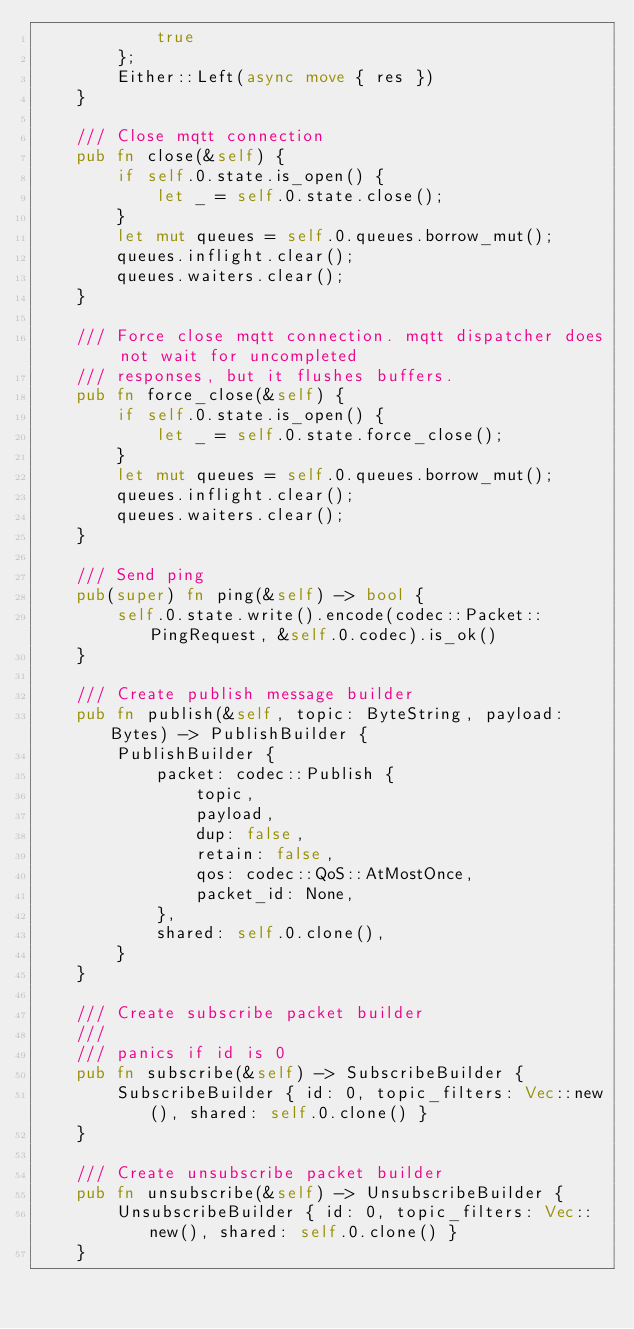<code> <loc_0><loc_0><loc_500><loc_500><_Rust_>            true
        };
        Either::Left(async move { res })
    }

    /// Close mqtt connection
    pub fn close(&self) {
        if self.0.state.is_open() {
            let _ = self.0.state.close();
        }
        let mut queues = self.0.queues.borrow_mut();
        queues.inflight.clear();
        queues.waiters.clear();
    }

    /// Force close mqtt connection. mqtt dispatcher does not wait for uncompleted
    /// responses, but it flushes buffers.
    pub fn force_close(&self) {
        if self.0.state.is_open() {
            let _ = self.0.state.force_close();
        }
        let mut queues = self.0.queues.borrow_mut();
        queues.inflight.clear();
        queues.waiters.clear();
    }

    /// Send ping
    pub(super) fn ping(&self) -> bool {
        self.0.state.write().encode(codec::Packet::PingRequest, &self.0.codec).is_ok()
    }

    /// Create publish message builder
    pub fn publish(&self, topic: ByteString, payload: Bytes) -> PublishBuilder {
        PublishBuilder {
            packet: codec::Publish {
                topic,
                payload,
                dup: false,
                retain: false,
                qos: codec::QoS::AtMostOnce,
                packet_id: None,
            },
            shared: self.0.clone(),
        }
    }

    /// Create subscribe packet builder
    ///
    /// panics if id is 0
    pub fn subscribe(&self) -> SubscribeBuilder {
        SubscribeBuilder { id: 0, topic_filters: Vec::new(), shared: self.0.clone() }
    }

    /// Create unsubscribe packet builder
    pub fn unsubscribe(&self) -> UnsubscribeBuilder {
        UnsubscribeBuilder { id: 0, topic_filters: Vec::new(), shared: self.0.clone() }
    }
</code> 